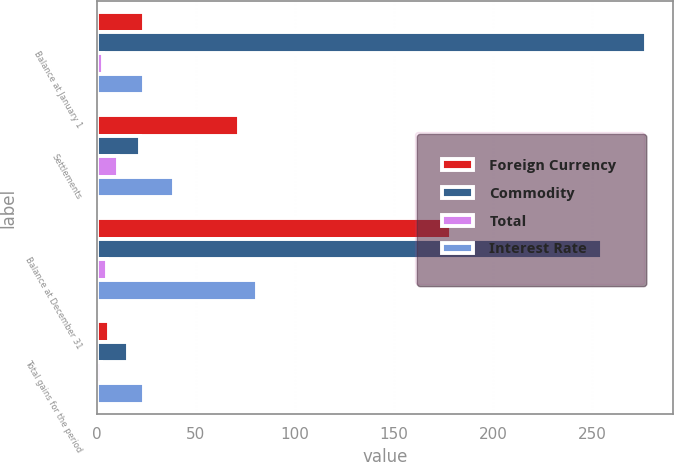Convert chart to OTSL. <chart><loc_0><loc_0><loc_500><loc_500><stacked_bar_chart><ecel><fcel>Balance at January 1<fcel>Settlements<fcel>Balance at December 31<fcel>Total gains for the period<nl><fcel>Foreign Currency<fcel>24<fcel>72<fcel>179<fcel>6<nl><fcel>Commodity<fcel>277<fcel>22<fcel>255<fcel>16<nl><fcel>Total<fcel>3<fcel>11<fcel>5<fcel>2<nl><fcel>Interest Rate<fcel>24<fcel>39<fcel>81<fcel>24<nl></chart> 